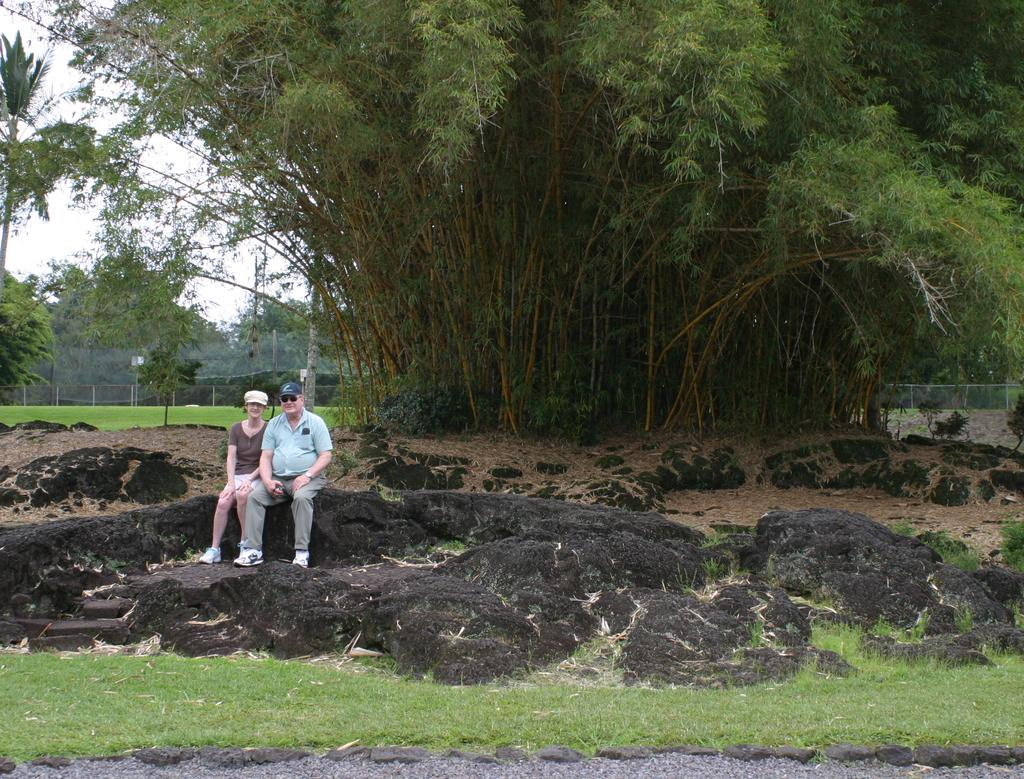How many people are sitting on the rock in the image? There are two persons sitting on a rock in the image. What is at the bottom of the image? There are rocks and green grass at the bottom of the image. What can be seen in the background of the image? There are many trees in the background of the image. Can you see a plough being used in the image? There is no plough present in the image. What type of sea creature can be seen swimming in the image? There is no sea creature present in the image. 